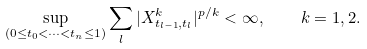<formula> <loc_0><loc_0><loc_500><loc_500>\sup _ { ( 0 \leq t _ { 0 } < \dots < t _ { n } \leq 1 ) } \sum _ { l } | X _ { t _ { l - 1 } , t _ { l } } ^ { k } | ^ { p / k } < \infty , \quad k = 1 , 2 .</formula> 